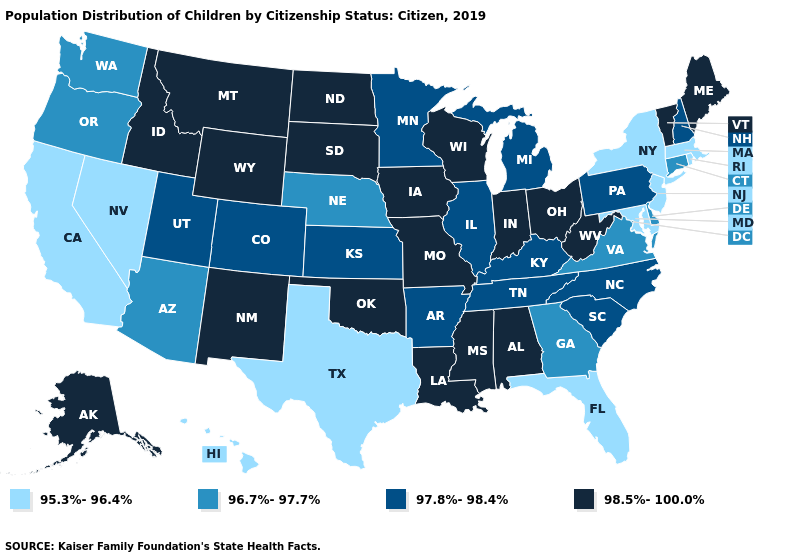What is the value of Maine?
Concise answer only. 98.5%-100.0%. Does Delaware have the highest value in the USA?
Be succinct. No. Name the states that have a value in the range 95.3%-96.4%?
Concise answer only. California, Florida, Hawaii, Maryland, Massachusetts, Nevada, New Jersey, New York, Rhode Island, Texas. Does the map have missing data?
Give a very brief answer. No. What is the lowest value in states that border Nevada?
Answer briefly. 95.3%-96.4%. Does Wyoming have the same value as Tennessee?
Concise answer only. No. Among the states that border Ohio , which have the lowest value?
Write a very short answer. Kentucky, Michigan, Pennsylvania. Does Massachusetts have a higher value than Washington?
Give a very brief answer. No. Does Missouri have the same value as Alaska?
Concise answer only. Yes. What is the value of Pennsylvania?
Keep it brief. 97.8%-98.4%. What is the value of Pennsylvania?
Keep it brief. 97.8%-98.4%. Among the states that border Idaho , which have the highest value?
Short answer required. Montana, Wyoming. What is the value of Pennsylvania?
Quick response, please. 97.8%-98.4%. Does Wyoming have a higher value than Iowa?
Quick response, please. No. Name the states that have a value in the range 96.7%-97.7%?
Be succinct. Arizona, Connecticut, Delaware, Georgia, Nebraska, Oregon, Virginia, Washington. 